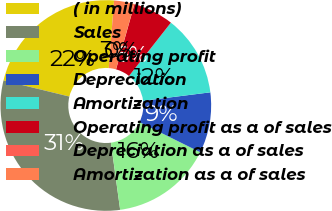Convert chart to OTSL. <chart><loc_0><loc_0><loc_500><loc_500><pie_chart><fcel>( in millions)<fcel>Sales<fcel>Operating profit<fcel>Depreciation<fcel>Amortization<fcel>Operating profit as a of sales<fcel>Depreciation as a of sales<fcel>Amortization as a of sales<nl><fcel>22.43%<fcel>30.99%<fcel>15.51%<fcel>9.31%<fcel>12.41%<fcel>6.21%<fcel>0.02%<fcel>3.12%<nl></chart> 